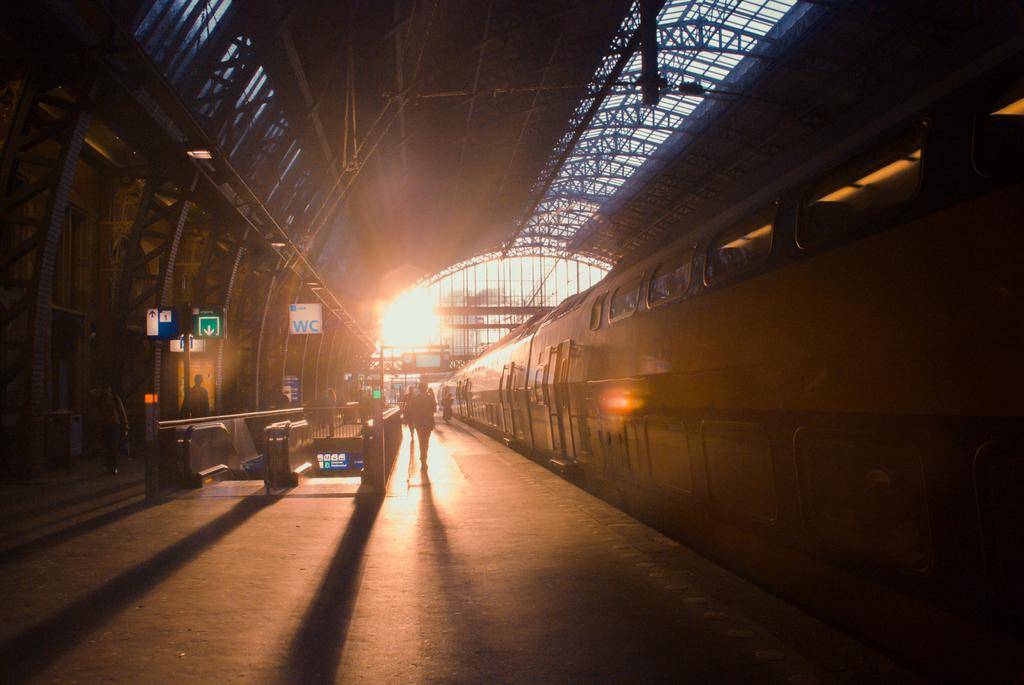<image>
Summarize the visual content of the image. A train in a covered station with a white sign stating WC in blue text in the background. 